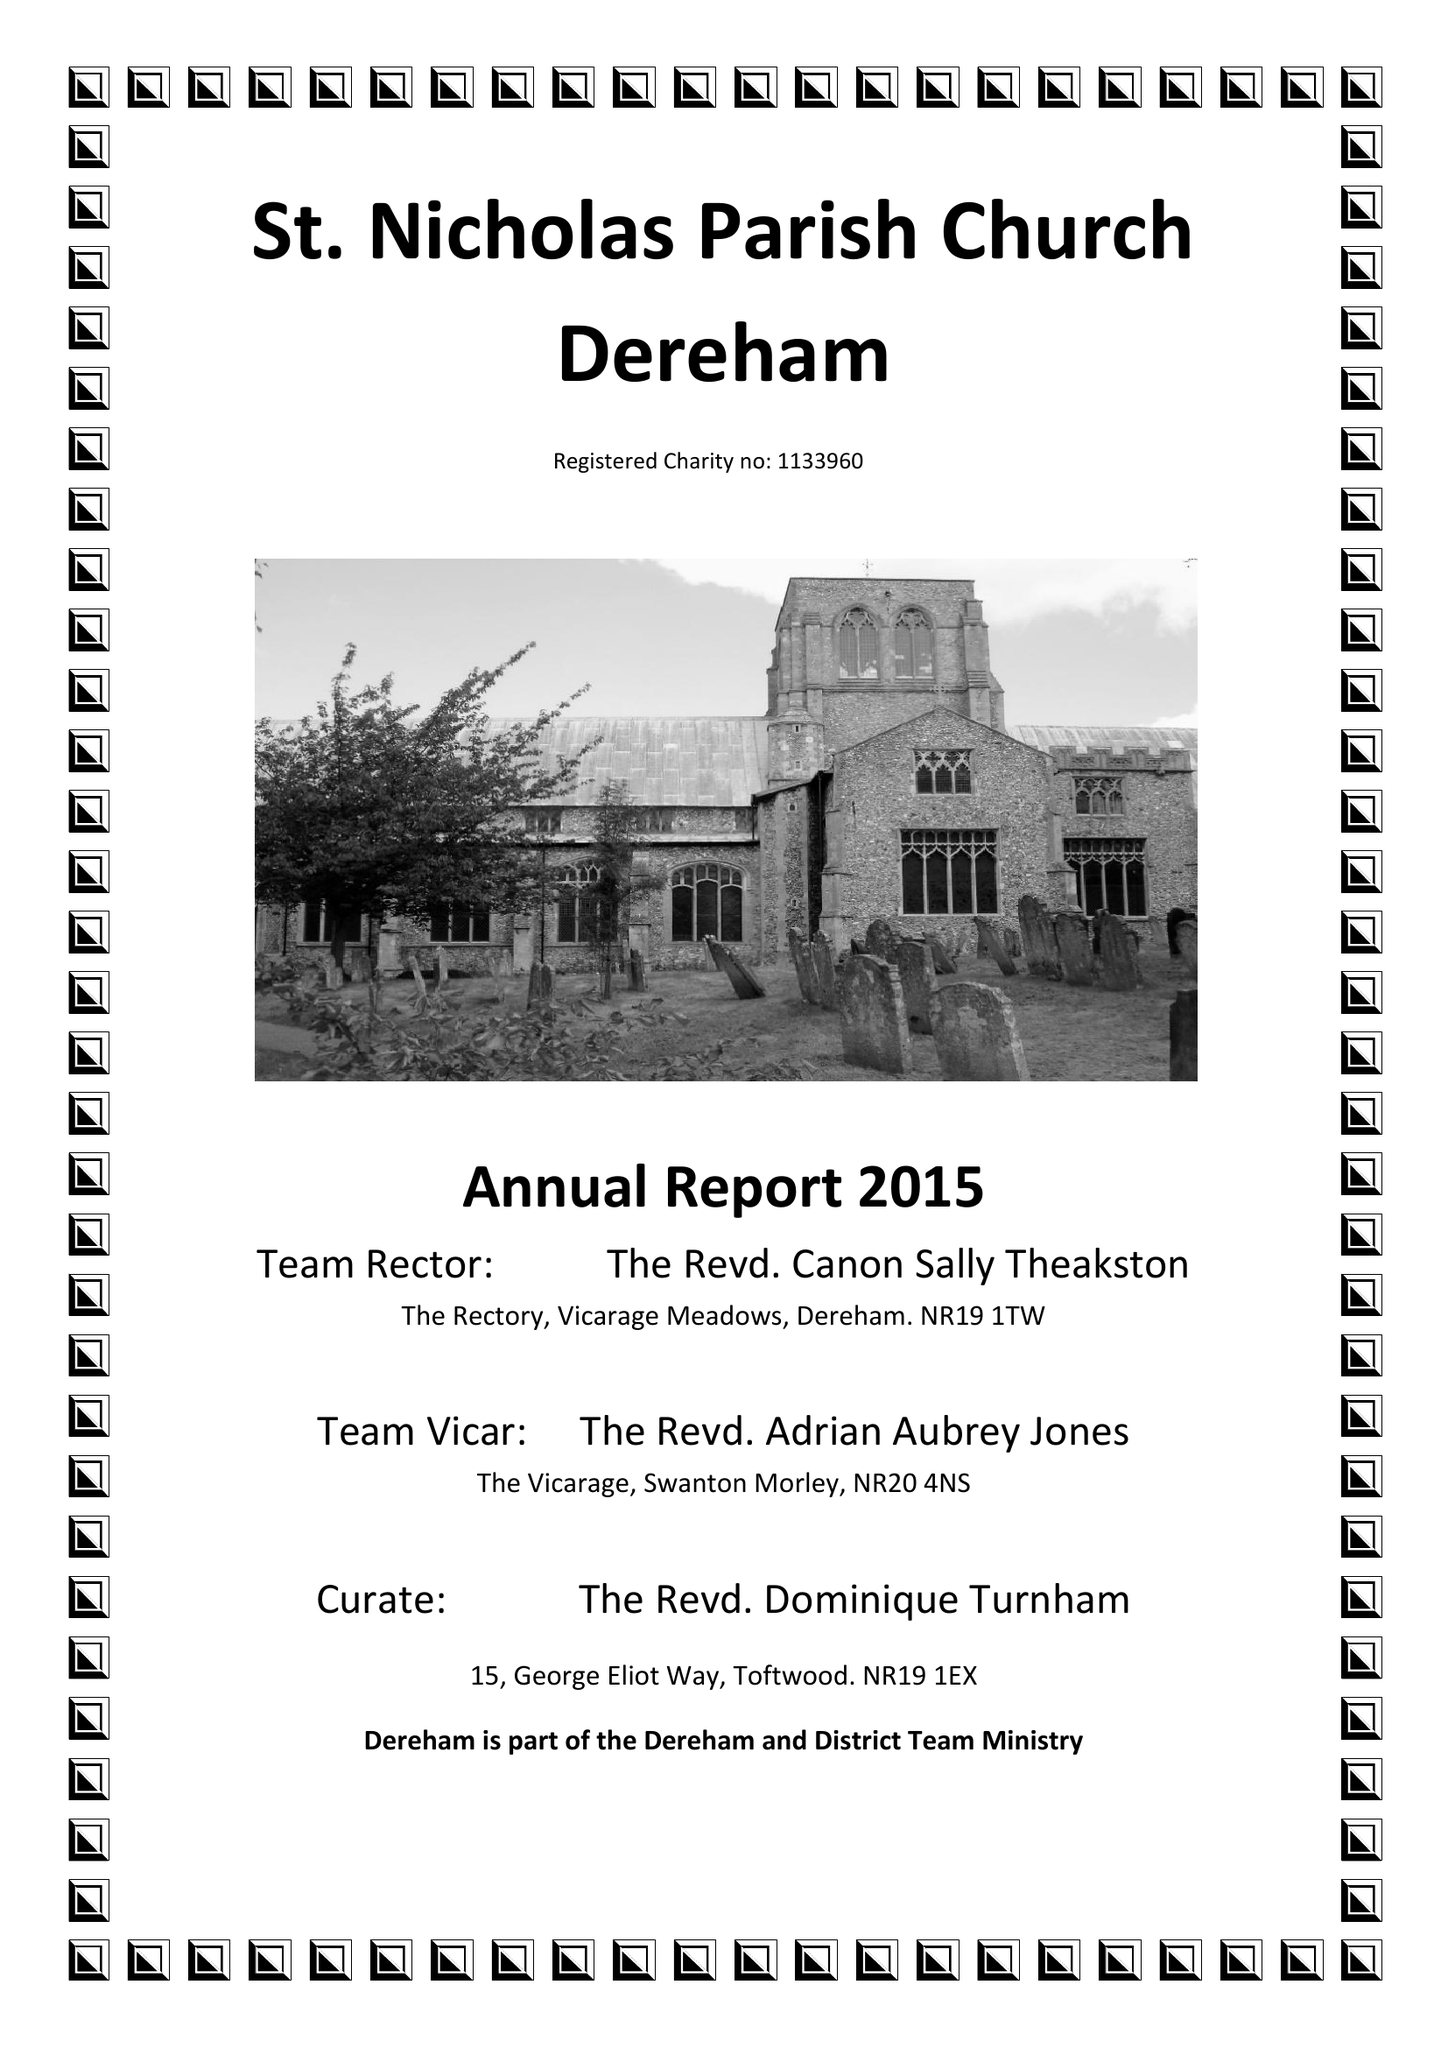What is the value for the income_annually_in_british_pounds?
Answer the question using a single word or phrase. 105377.00 